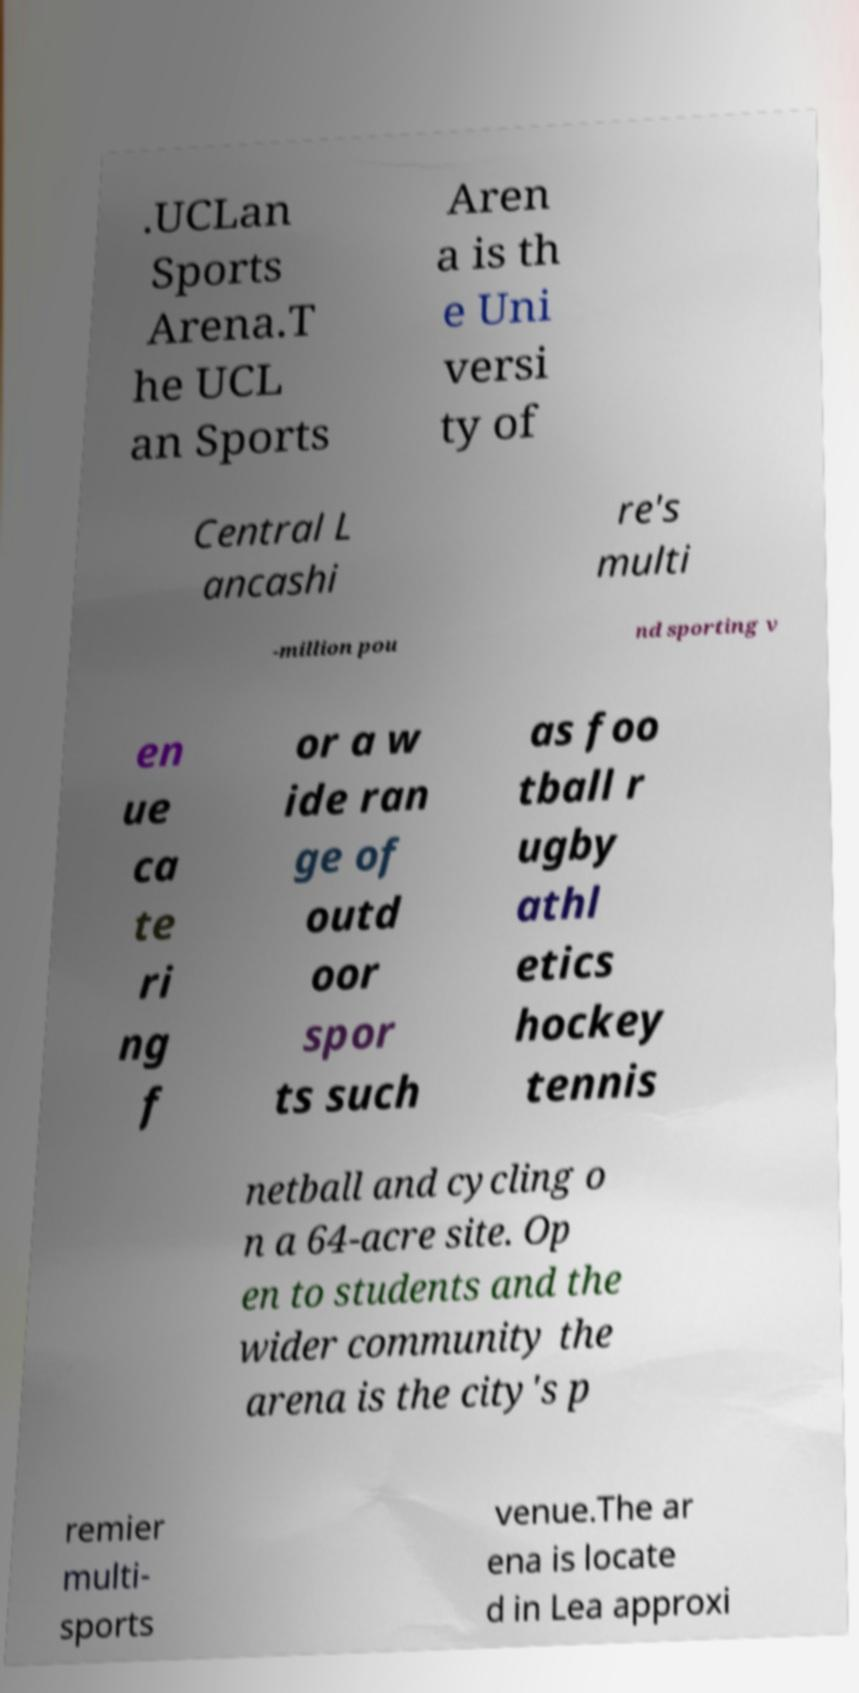I need the written content from this picture converted into text. Can you do that? .UCLan Sports Arena.T he UCL an Sports Aren a is th e Uni versi ty of Central L ancashi re's multi -million pou nd sporting v en ue ca te ri ng f or a w ide ran ge of outd oor spor ts such as foo tball r ugby athl etics hockey tennis netball and cycling o n a 64-acre site. Op en to students and the wider community the arena is the city's p remier multi- sports venue.The ar ena is locate d in Lea approxi 